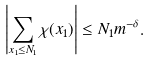Convert formula to latex. <formula><loc_0><loc_0><loc_500><loc_500>\left | \sum _ { x _ { 1 } \leq N _ { 1 } } \chi ( x _ { 1 } ) \right | \leq N _ { 1 } m ^ { - \delta } .</formula> 